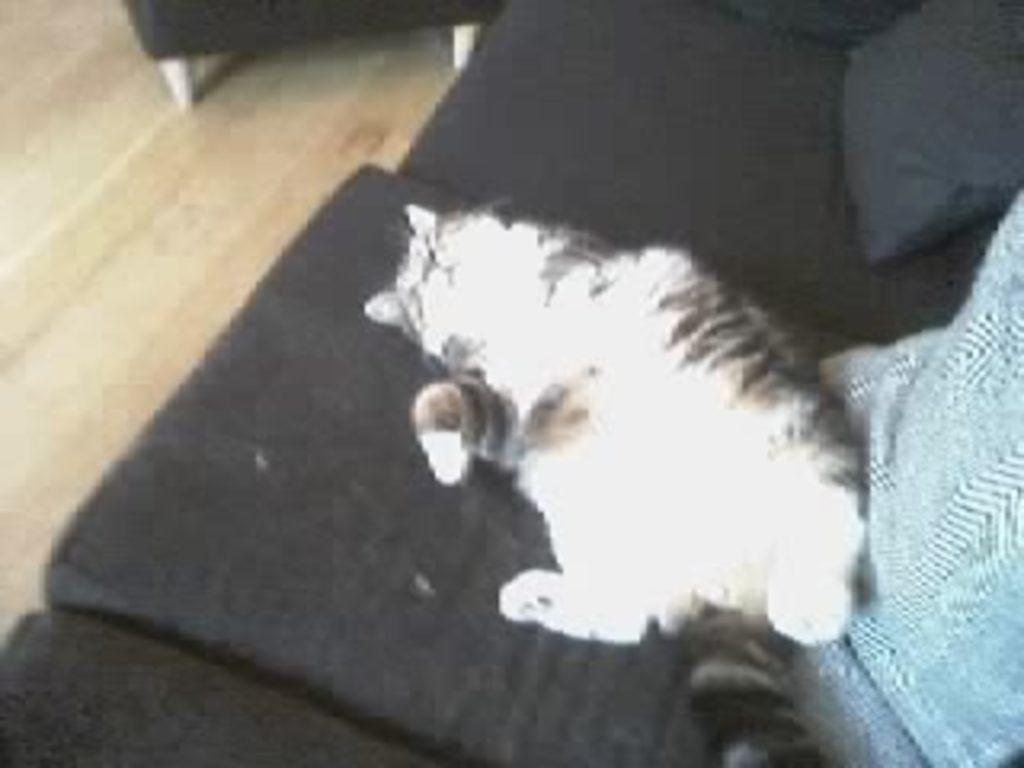What type of animal is in the image? There is a cat in the image. What is the cat doing in the image? The cat is sleeping. Where is the cat located in the image? The cat is on a black sofa. What color is the object beside the cat? There is a blue color object beside the cat. What type of meal is the cat eating in the image? The cat is not eating a meal in the image; it is sleeping. What is the cat using to brush its teeth in the image? There is no indication of the cat brushing its teeth or using a mouth-related object in the image. 